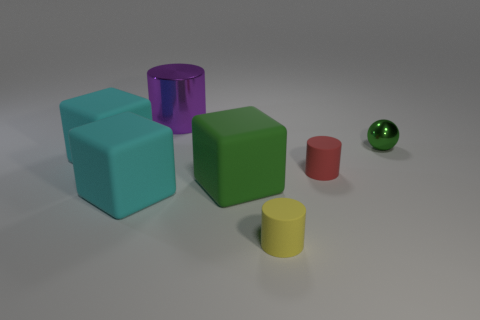Does the red thing have the same material as the purple thing?
Your answer should be compact. No. How many other objects are there of the same shape as the small yellow matte object?
Make the answer very short. 2. Is there anything else that is the same material as the green ball?
Your answer should be very brief. Yes. There is a tiny object that is behind the block left of the big cyan rubber cube that is in front of the tiny red matte cylinder; what color is it?
Your response must be concise. Green. Do the tiny rubber thing that is on the right side of the small yellow cylinder and the tiny yellow thing have the same shape?
Give a very brief answer. Yes. How many tiny blue cubes are there?
Your answer should be very brief. 0. What number of purple cylinders are the same size as the purple thing?
Offer a very short reply. 0. What material is the purple cylinder?
Ensure brevity in your answer.  Metal. There is a large cylinder; is it the same color as the matte cylinder that is in front of the small red cylinder?
Your response must be concise. No. There is a object that is right of the yellow rubber object and to the left of the small green metal thing; how big is it?
Provide a short and direct response. Small. 